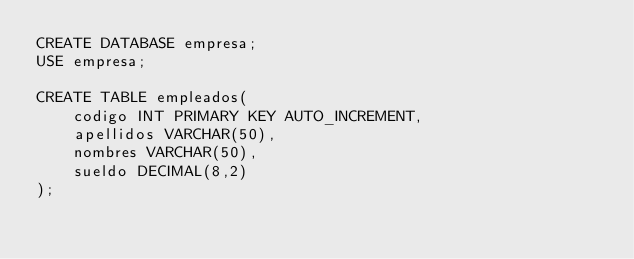Convert code to text. <code><loc_0><loc_0><loc_500><loc_500><_SQL_>CREATE DATABASE empresa;
USE empresa;

CREATE TABLE empleados(
	codigo INT PRIMARY KEY AUTO_INCREMENT,
	apellidos VARCHAR(50),
	nombres VARCHAR(50),
	sueldo DECIMAL(8,2)
);</code> 